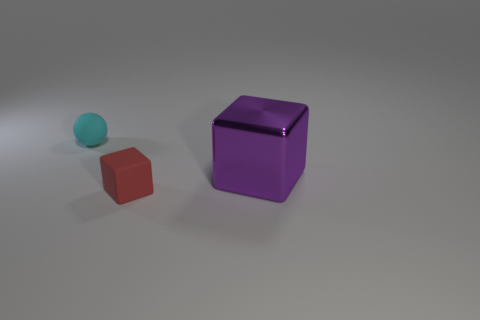Can you describe the lighting in the scene? The lighting in the scene is soft and ambient, with what appears to be a single light source above the objects, casting subtle shadows on the ground. 